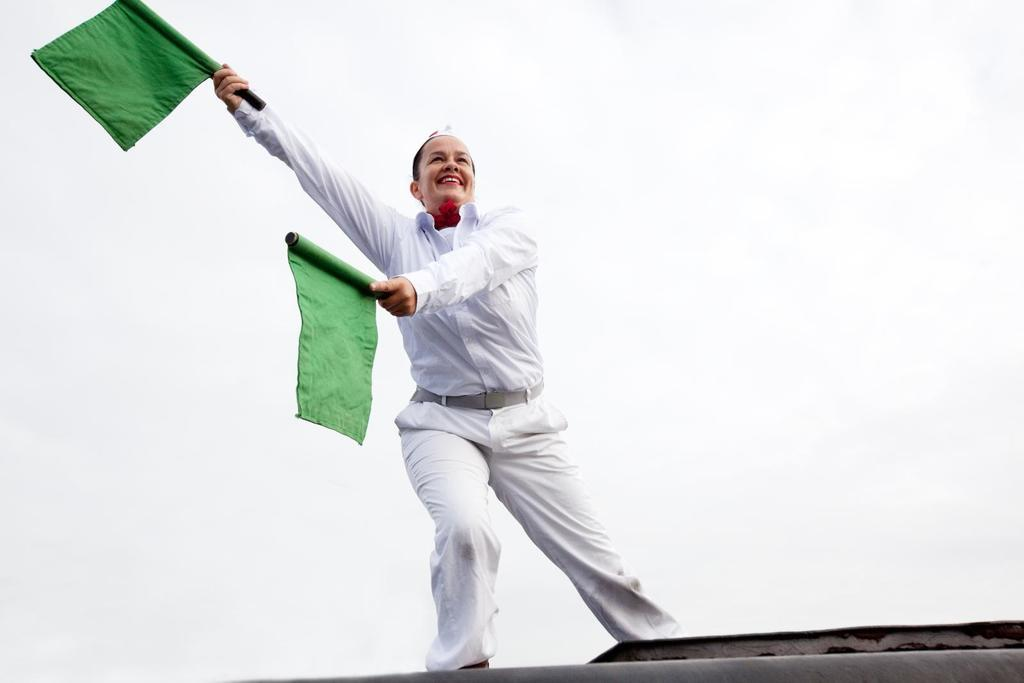Who is present in the image? There is a person in the image. What is the person wearing? The person is wearing a white dress. What is the person holding in their hands? The person is holding green flags in their hands. Where is the parent sitting on the sofa in the image? There is no parent or sofa present in the image. What color is the chalk used by the person in the image? There is no chalk present in the image; the person is holding green flags. 